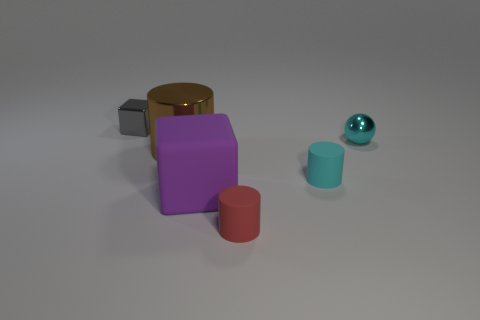Does the cube that is to the left of the purple object have the same material as the cylinder that is on the right side of the tiny red thing?
Provide a short and direct response. No. How many metal objects are either purple objects or tiny gray objects?
Your answer should be very brief. 1. The big object that is in front of the cyan thing that is on the left side of the tiny cyan thing that is behind the big brown thing is made of what material?
Your answer should be compact. Rubber. Is the shape of the small cyan thing on the left side of the cyan ball the same as the big thing that is to the left of the purple matte thing?
Your answer should be very brief. Yes. What color is the block that is in front of the small shiny thing that is right of the tiny gray metallic object?
Ensure brevity in your answer.  Purple. What number of spheres are brown things or small gray things?
Make the answer very short. 0. There is a cyan thing left of the small shiny thing that is in front of the small gray object; how many matte cubes are on the right side of it?
Offer a very short reply. 0. What is the size of the thing that is the same color as the ball?
Provide a short and direct response. Small. Is there a small green block made of the same material as the small red object?
Keep it short and to the point. No. Is the material of the purple block the same as the red cylinder?
Keep it short and to the point. Yes. 